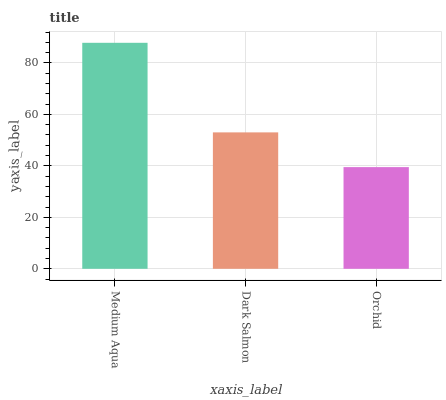Is Orchid the minimum?
Answer yes or no. Yes. Is Medium Aqua the maximum?
Answer yes or no. Yes. Is Dark Salmon the minimum?
Answer yes or no. No. Is Dark Salmon the maximum?
Answer yes or no. No. Is Medium Aqua greater than Dark Salmon?
Answer yes or no. Yes. Is Dark Salmon less than Medium Aqua?
Answer yes or no. Yes. Is Dark Salmon greater than Medium Aqua?
Answer yes or no. No. Is Medium Aqua less than Dark Salmon?
Answer yes or no. No. Is Dark Salmon the high median?
Answer yes or no. Yes. Is Dark Salmon the low median?
Answer yes or no. Yes. Is Medium Aqua the high median?
Answer yes or no. No. Is Medium Aqua the low median?
Answer yes or no. No. 